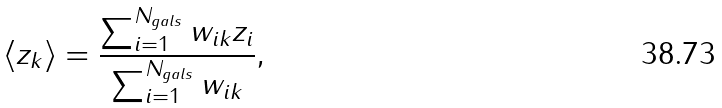<formula> <loc_0><loc_0><loc_500><loc_500>\langle z _ { k } \rangle = \frac { \sum _ { i = 1 } ^ { N _ { g a l s } } w _ { i k } z _ { i } } { \sum _ { i = 1 } ^ { N _ { g a l s } } w _ { i k } } ,</formula> 